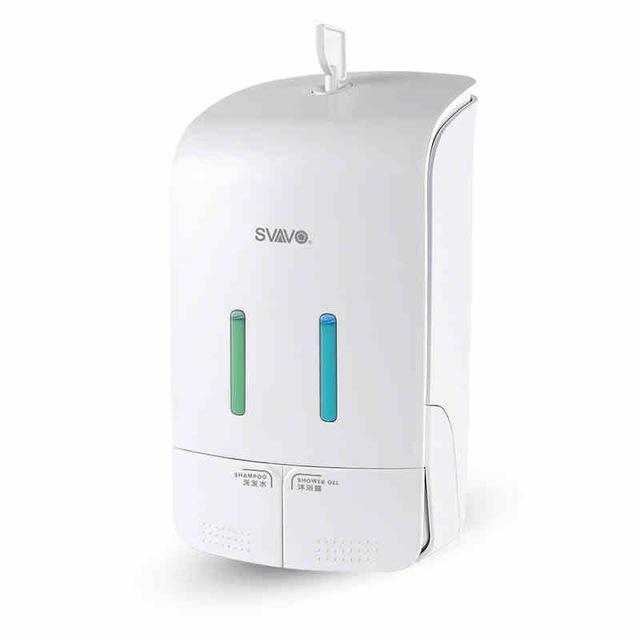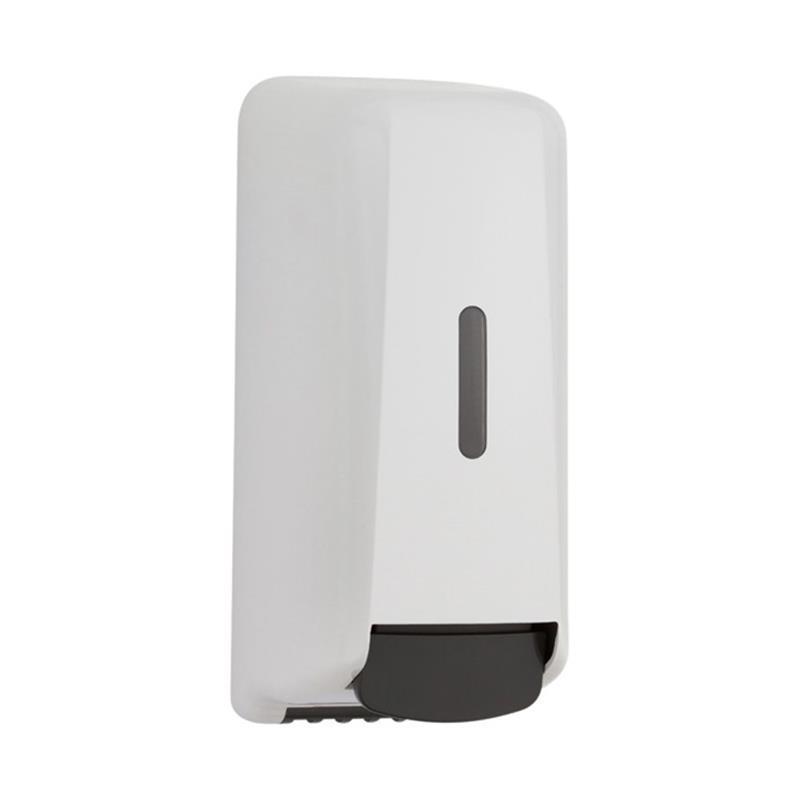The first image is the image on the left, the second image is the image on the right. Evaluate the accuracy of this statement regarding the images: "One of these is silver in color.". Is it true? Answer yes or no. No. The first image is the image on the left, the second image is the image on the right. Evaluate the accuracy of this statement regarding the images: "An image features a cylindrical dispenser with chrome finish.". Is it true? Answer yes or no. No. 